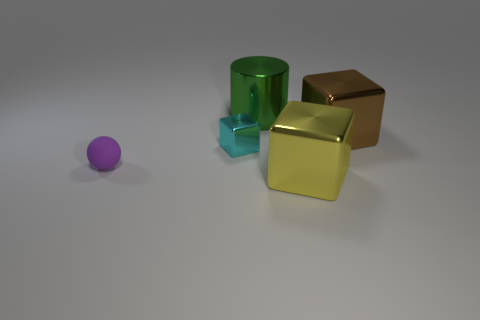What number of red matte cylinders are there? There are no red matte cylinders visible in the image. The objects depicted include a purple sphere, a green cylinder, a blue cube, and two matte cubes, one bronze and one yellow-gold. 